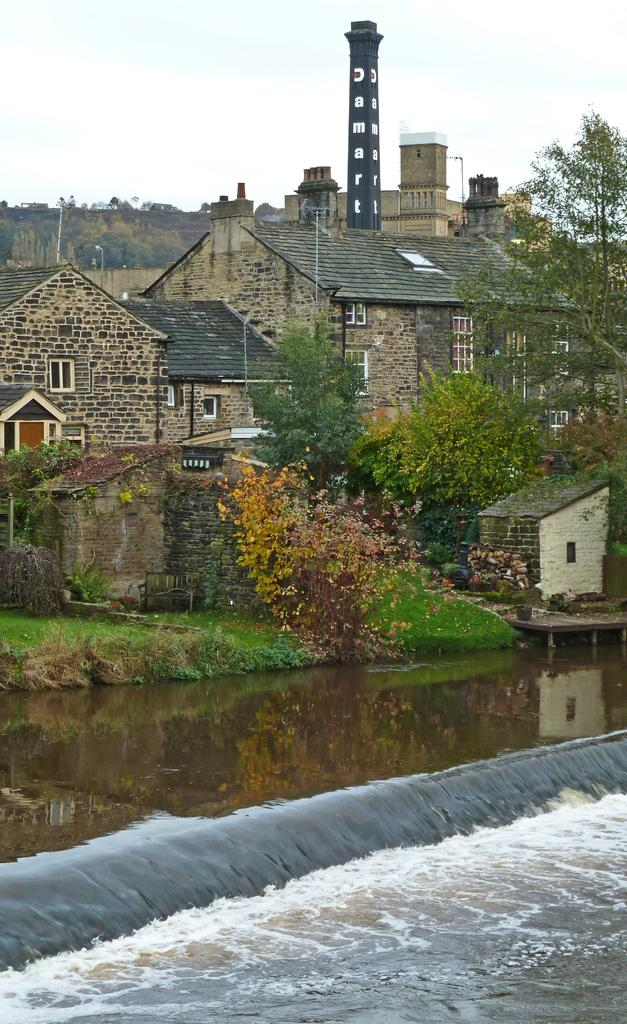What is visible in the image? Water is visible in the image. What can be seen near the water? There are many trees and buildings near the water. What is visible in the background of the image? The sky is visible in the background of the image. How many cows can be seen grazing near the water in the image? There are no cows visible in the image. Are there any bears interacting with the trees near the water in the image? There are no bears present in the image. 